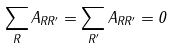<formula> <loc_0><loc_0><loc_500><loc_500>\sum _ { R } A _ { R R ^ { \prime } } = \sum _ { R ^ { \prime } } A _ { R R ^ { \prime } } = 0</formula> 